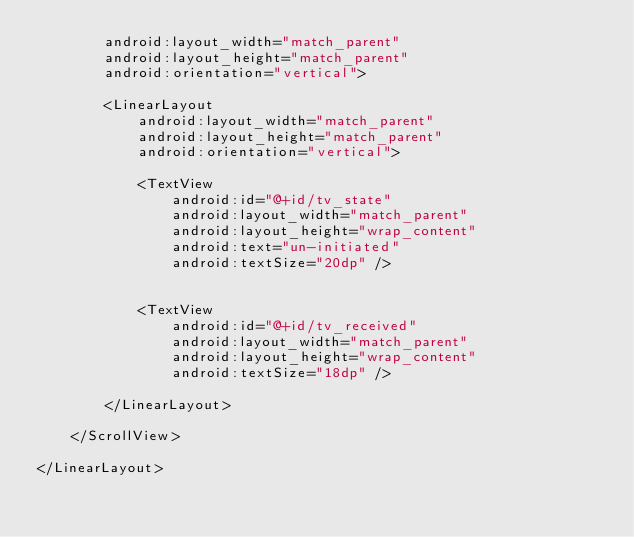Convert code to text. <code><loc_0><loc_0><loc_500><loc_500><_XML_>        android:layout_width="match_parent"
        android:layout_height="match_parent"
        android:orientation="vertical">

        <LinearLayout
            android:layout_width="match_parent"
            android:layout_height="match_parent"
            android:orientation="vertical">

            <TextView
                android:id="@+id/tv_state"
                android:layout_width="match_parent"
                android:layout_height="wrap_content"
                android:text="un-initiated"
                android:textSize="20dp" />


            <TextView
                android:id="@+id/tv_received"
                android:layout_width="match_parent"
                android:layout_height="wrap_content"
                android:textSize="18dp" />

        </LinearLayout>

    </ScrollView>

</LinearLayout>
</code> 